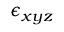Convert formula to latex. <formula><loc_0><loc_0><loc_500><loc_500>\epsilon _ { x y z }</formula> 